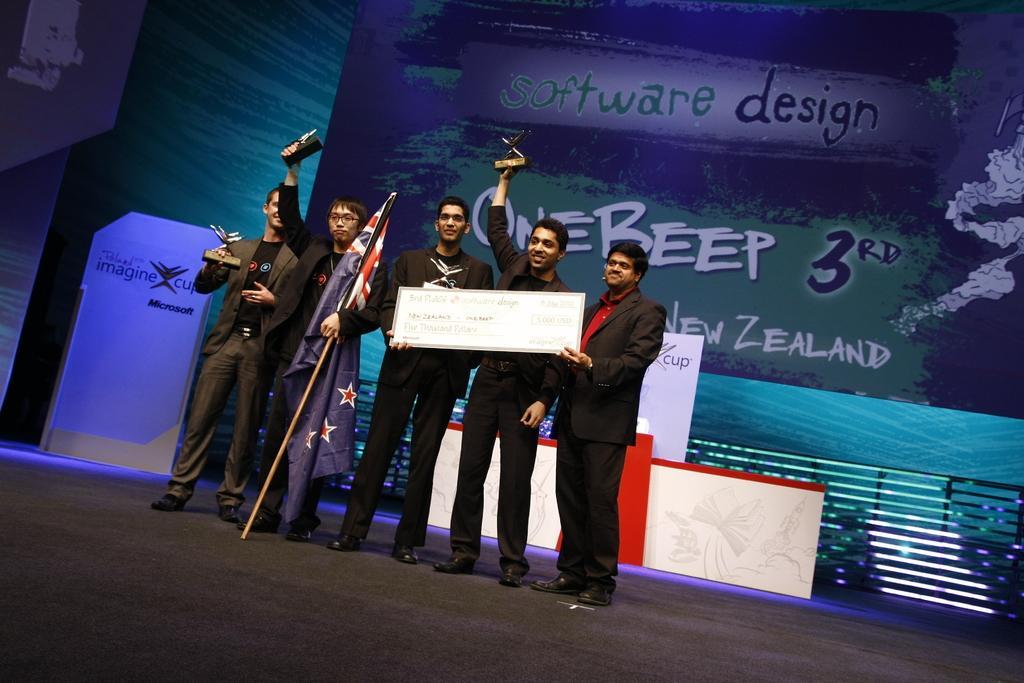In one or two sentences, can you explain what this image depicts? In this image we can see a group of people are standing on a stage, they are wearing a black suit, and holding a cheque in the hand, there a man is holding a flag in the hand, at the back there is a table, there is a banner. 